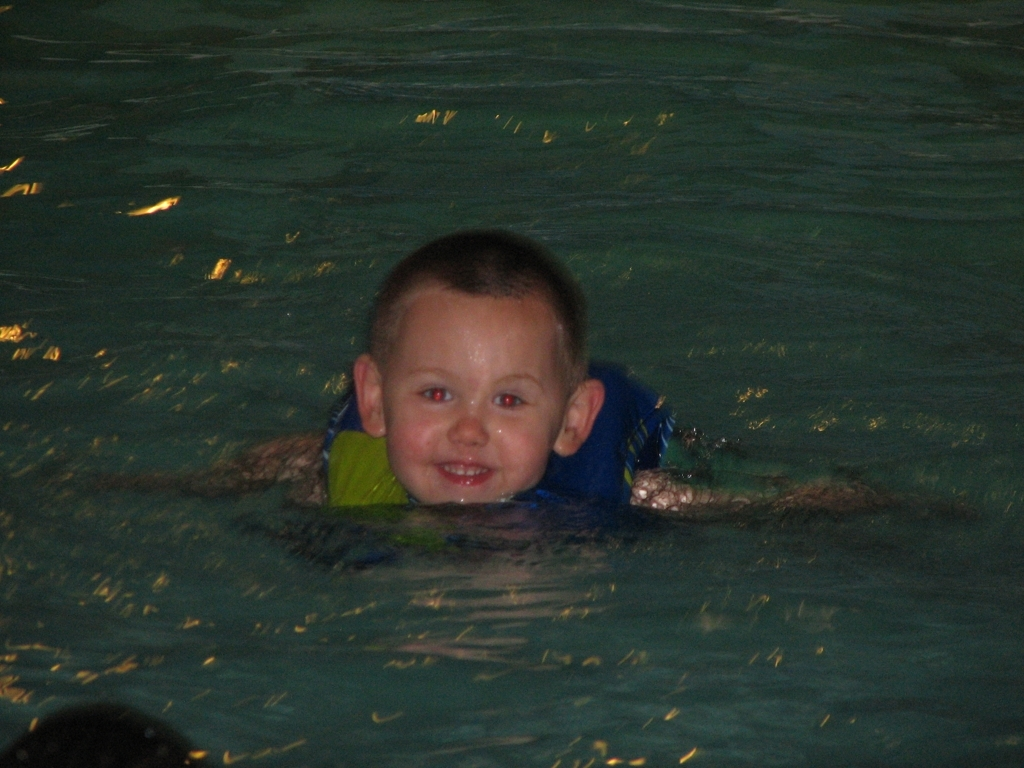Can you tell me about the lighting in this indoor pool? The lighting in the indoor pool seems to be artificial, likely from overhead fixtures, which cast reflections on the surface of the water, creating a shimmering effect. 